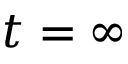<formula> <loc_0><loc_0><loc_500><loc_500>t = \infty</formula> 